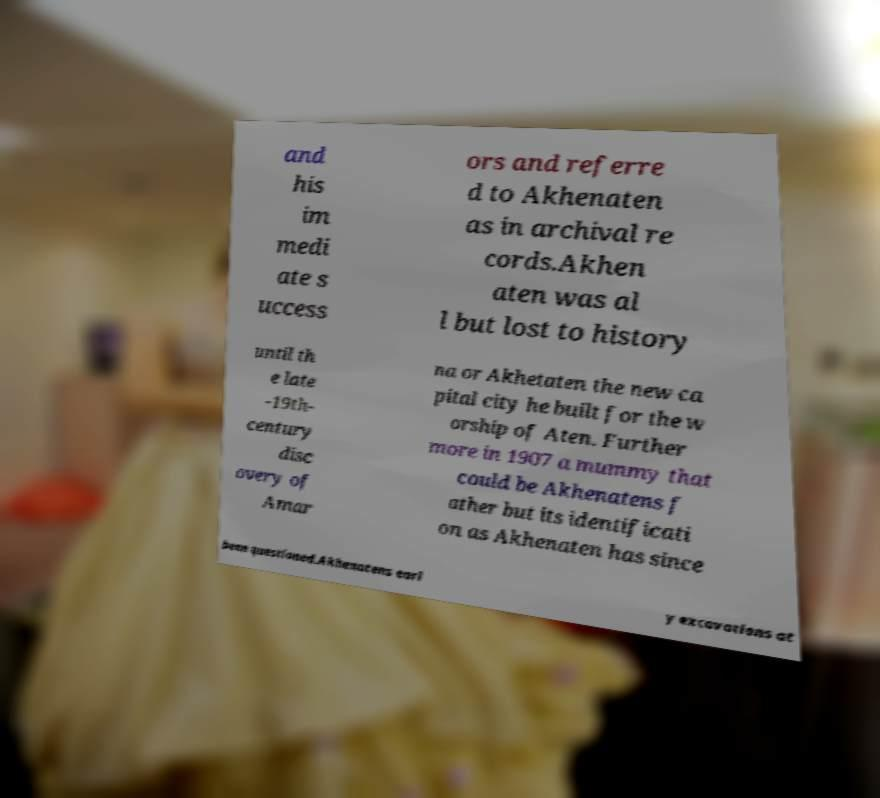Could you assist in decoding the text presented in this image and type it out clearly? and his im medi ate s uccess ors and referre d to Akhenaten as in archival re cords.Akhen aten was al l but lost to history until th e late -19th- century disc overy of Amar na or Akhetaten the new ca pital city he built for the w orship of Aten. Further more in 1907 a mummy that could be Akhenatens f ather but its identificati on as Akhenaten has since been questioned.Akhenatens earl y excavations at 